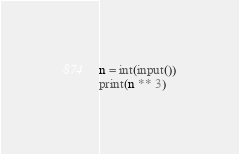<code> <loc_0><loc_0><loc_500><loc_500><_Python_>n = int(input())
print(n ** 3)</code> 